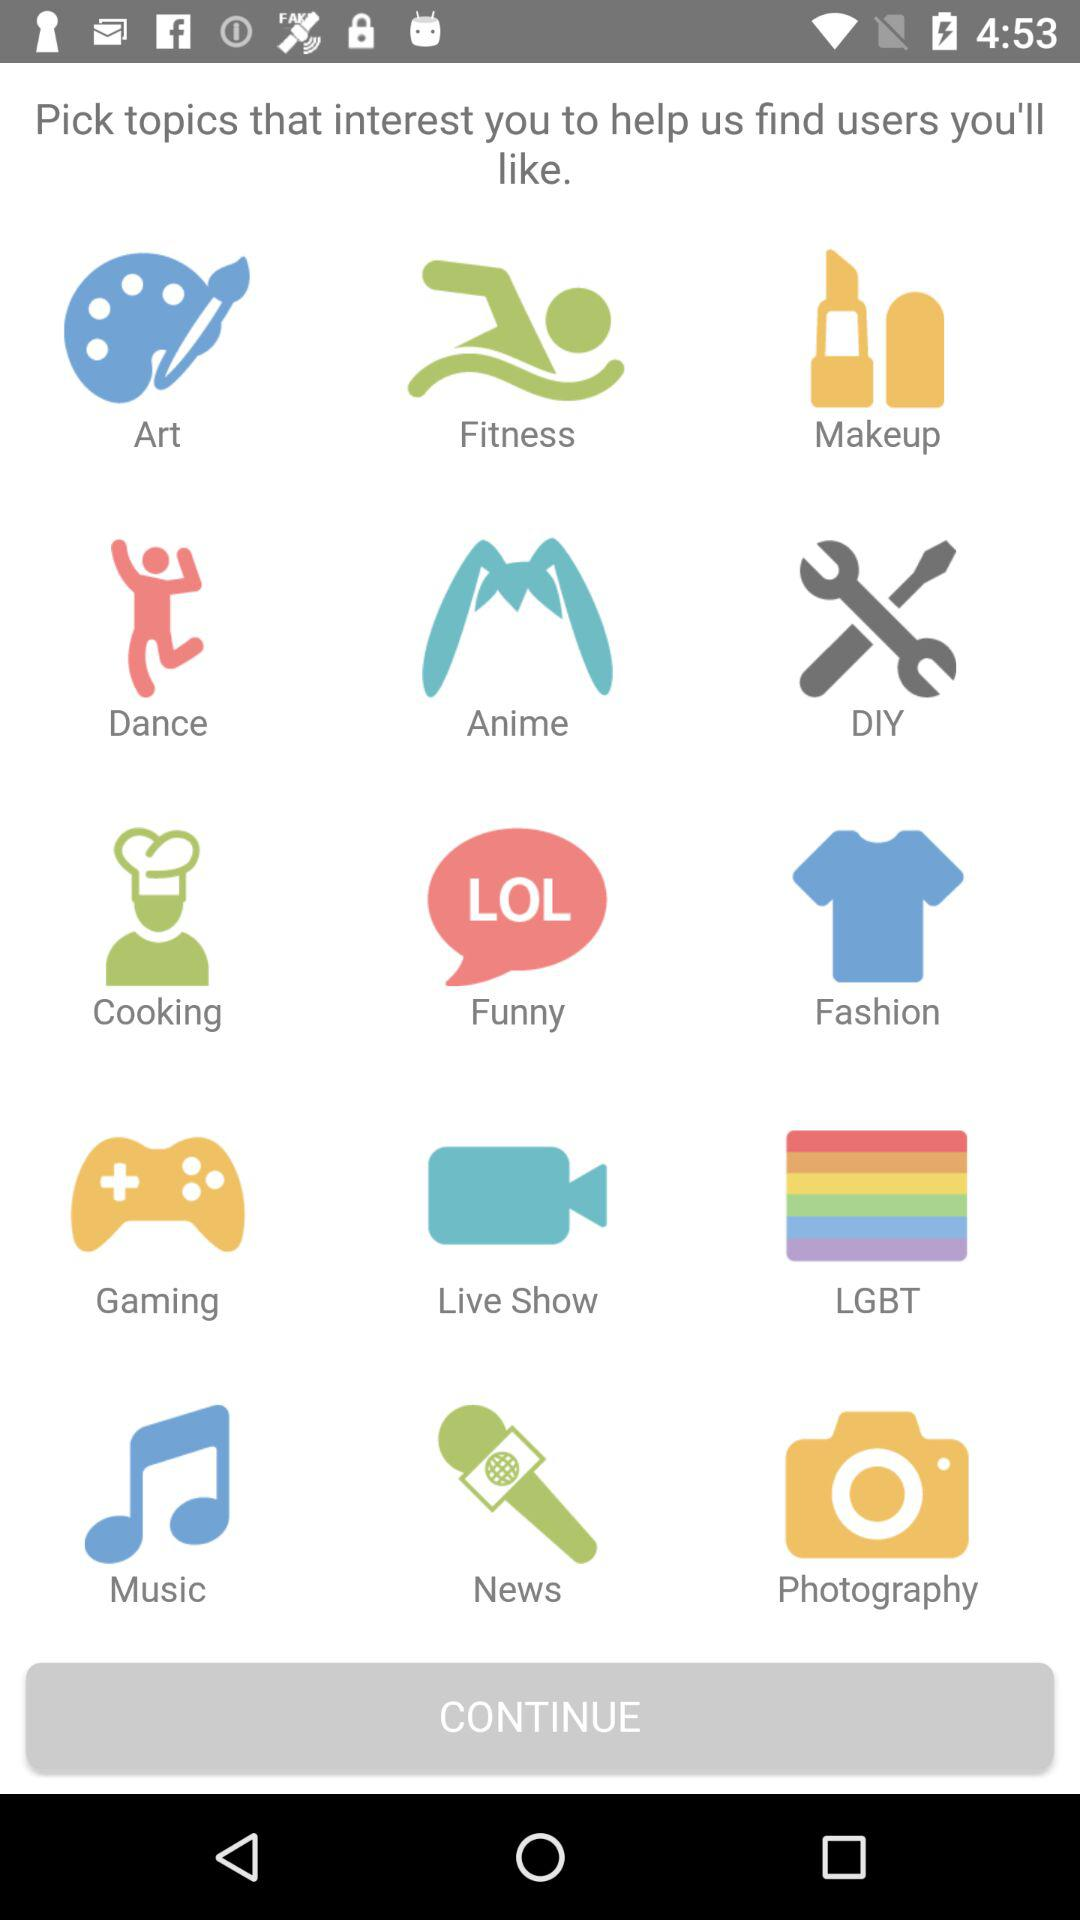What are the various interesting topics to pick for finding similar users? The various interesting topics are "Art", "Fitness", "Makeup", "Dance", "Anime", "DIY", "Cooking", "Funny", "Fashion", "Gaming", "Live Show", "LGBT", "Music", "News" and "Photography". 